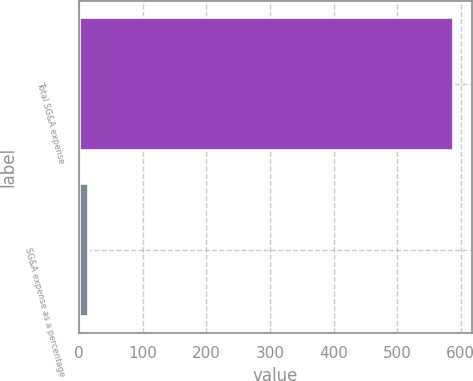<chart> <loc_0><loc_0><loc_500><loc_500><bar_chart><fcel>Total SG&A expense<fcel>SG&A expense as a percentage<nl><fcel>588<fcel>14.3<nl></chart> 